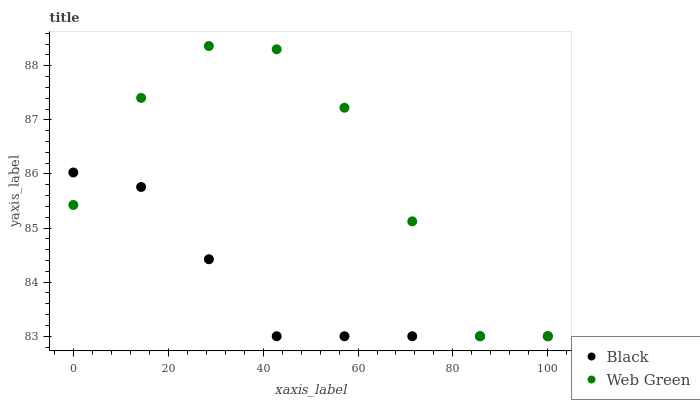Does Black have the minimum area under the curve?
Answer yes or no. Yes. Does Web Green have the maximum area under the curve?
Answer yes or no. Yes. Does Web Green have the minimum area under the curve?
Answer yes or no. No. Is Black the smoothest?
Answer yes or no. Yes. Is Web Green the roughest?
Answer yes or no. Yes. Is Web Green the smoothest?
Answer yes or no. No. Does Black have the lowest value?
Answer yes or no. Yes. Does Web Green have the highest value?
Answer yes or no. Yes. Does Black intersect Web Green?
Answer yes or no. Yes. Is Black less than Web Green?
Answer yes or no. No. Is Black greater than Web Green?
Answer yes or no. No. 